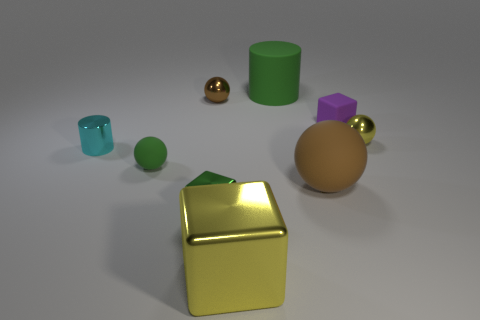Add 1 small cyan rubber things. How many objects exist? 10 Subtract all blocks. How many objects are left? 6 Subtract all green shiny cubes. Subtract all tiny green shiny objects. How many objects are left? 7 Add 5 green matte spheres. How many green matte spheres are left? 6 Add 2 brown objects. How many brown objects exist? 4 Subtract 0 red balls. How many objects are left? 9 